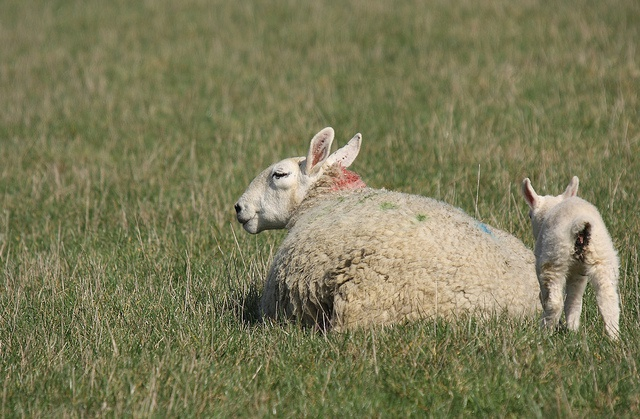Describe the objects in this image and their specific colors. I can see sheep in olive and tan tones and sheep in olive, gray, darkgray, tan, and lightgray tones in this image. 